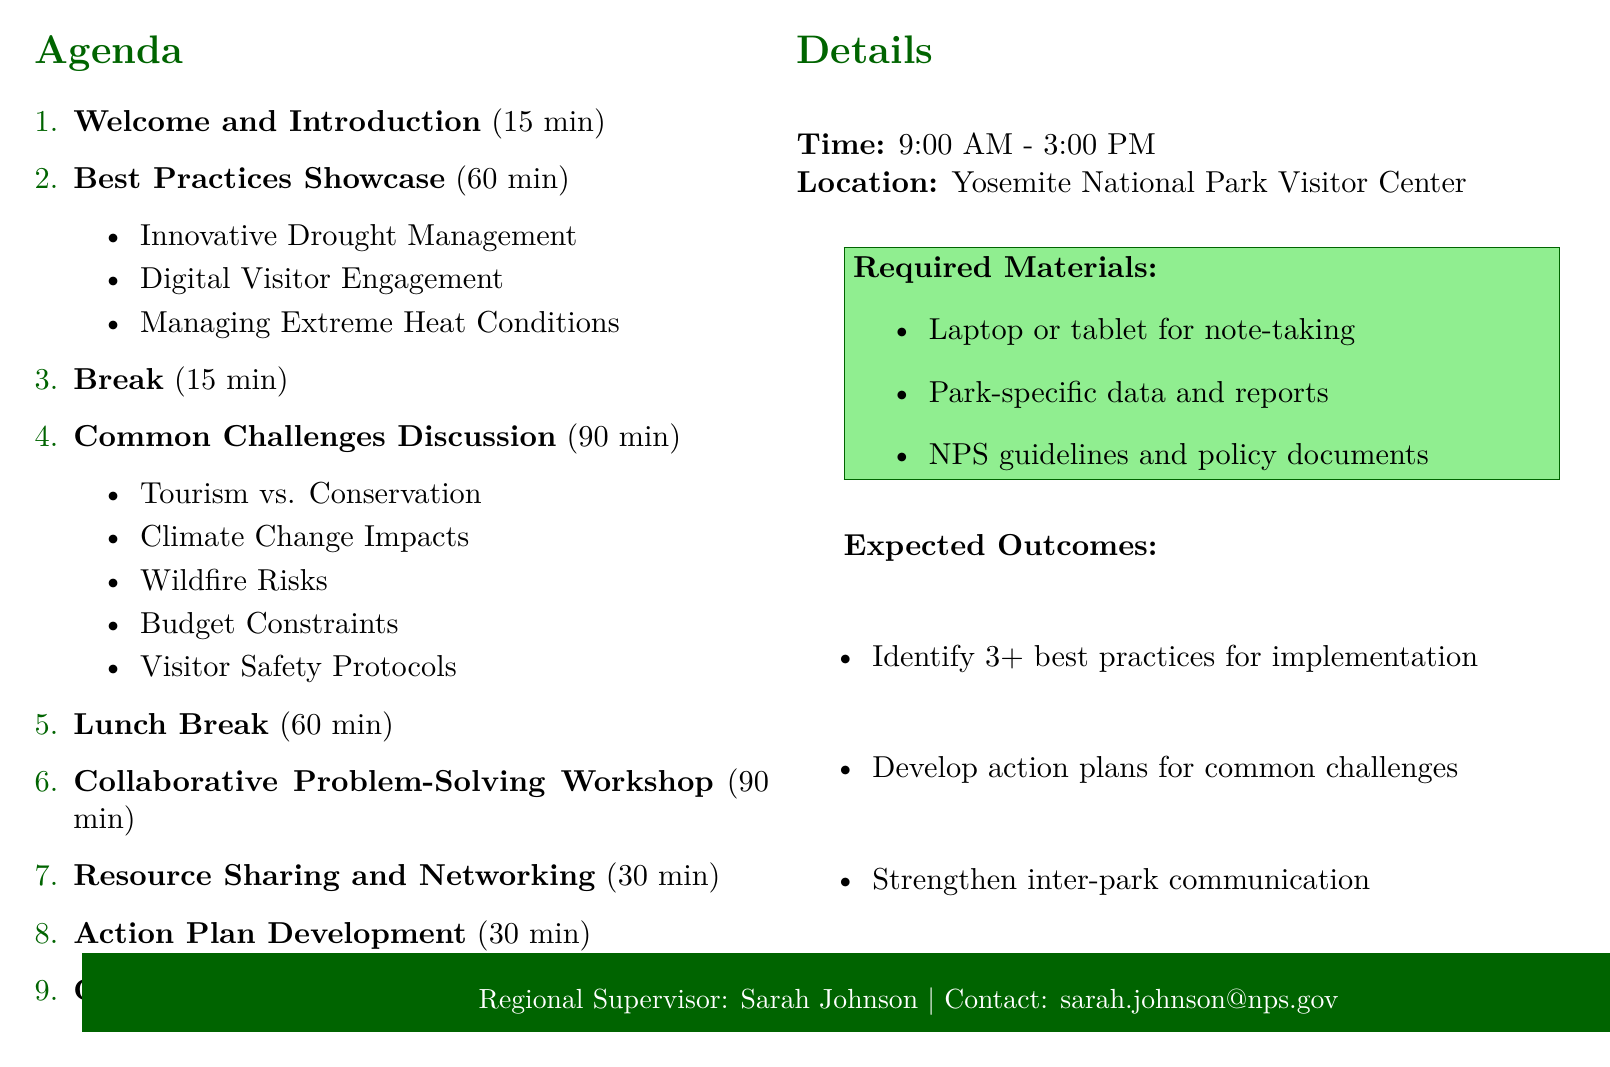what is the date of the session? The date is explicitly stated in the document under session details.
Answer: July 15, 2023 who is facilitating the Common Challenges Discussion? The facilitator's name is mentioned alongside the duration and description of the session.
Answer: Dr. Emily Watson how long is the Best Practices Showcase? The duration is provided next to the title in the agenda section.
Answer: 60 minutes which park is Mark Thompson from? Mark's affiliation is included in the presenters' list during the Best Practices Showcase.
Answer: Joshua Tree National Park what are the expected outcomes of the session? The expected outcomes are listed under a specific section in the document.
Answer: Identification of at least three best practices to be implemented across parks what topic does Robert Garcia cover? The topic is specified in the Best Practices Showcase section alongside the presenter's name.
Answer: Effective Strategies for Managing Extreme Heat Conditions how long is the Collaborative Problem-Solving Workshop? The workshop's duration is clearly listed in the agenda items.
Answer: 90 minutes who is presenting the Welcome and Introduction? The presenter of this agenda item is mentioned at the beginning of the session details.
Answer: Sarah Johnson what is the location of the session? The location is stated clearly in the details section just before the expected outcomes.
Answer: Yosemite National Park Visitor Center 